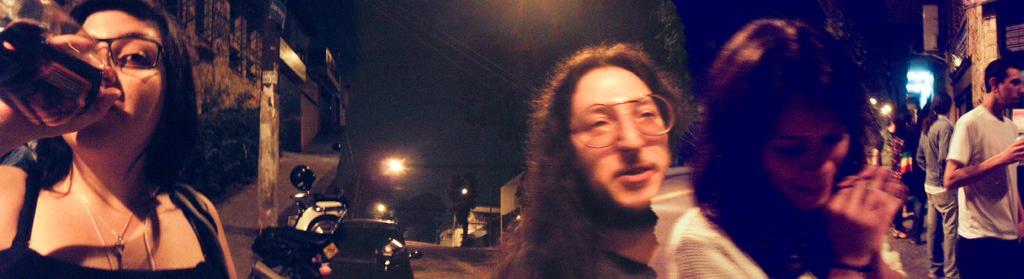Please provide a concise description of this image. This is the picture of a road. On the left side of the image there is a woman standing and holding the bottle and there are buildings and vehicles and there is a pole on the footpath. In the middle of the image there are two persons and there are buildings and there is a tree and pole. On the left side of the image there are group of people standing and there are buildings. At the top there is sky. At the bottom there is a road. 